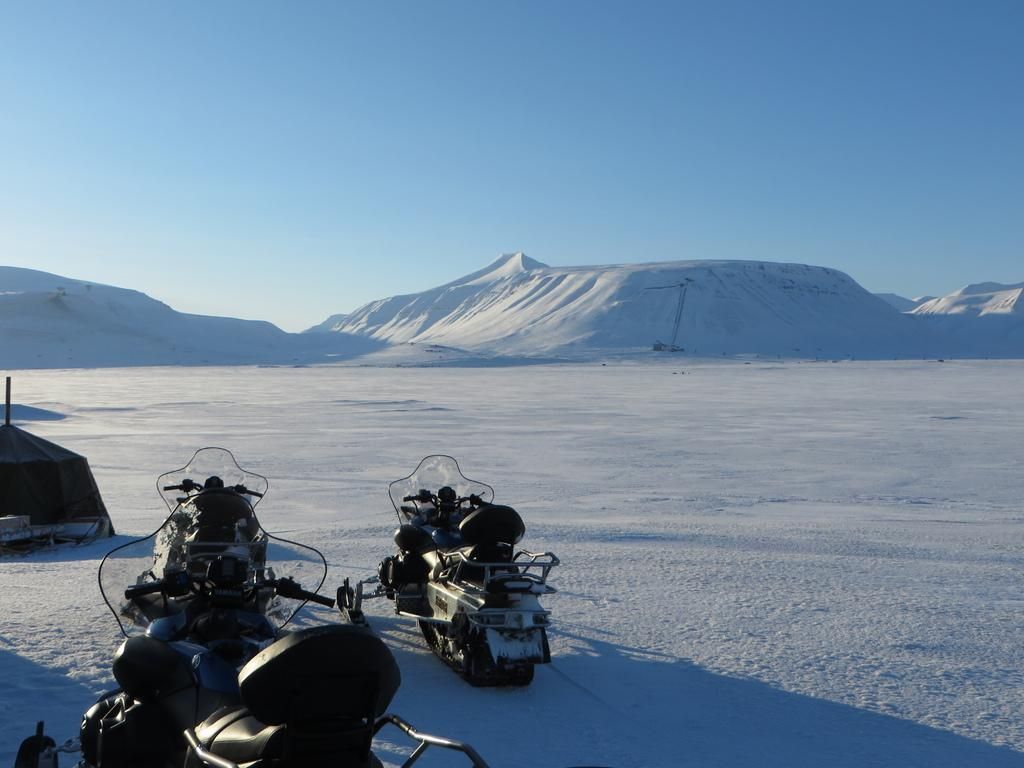What can be seen on the left side of the image? There are vehicles on the left side of the image. What is the weather like in the image? There is snow in the image, and the sky is sunny. What type of terrain is visible in the center of the image? There are hills covered with snow in the center of the image. What type of animal is seen covered in wax in the image? There is no animal or wax present in the image. How can one join the vehicles on the left side of the image? The image does not provide information on how to join the vehicles; it only shows their presence. 